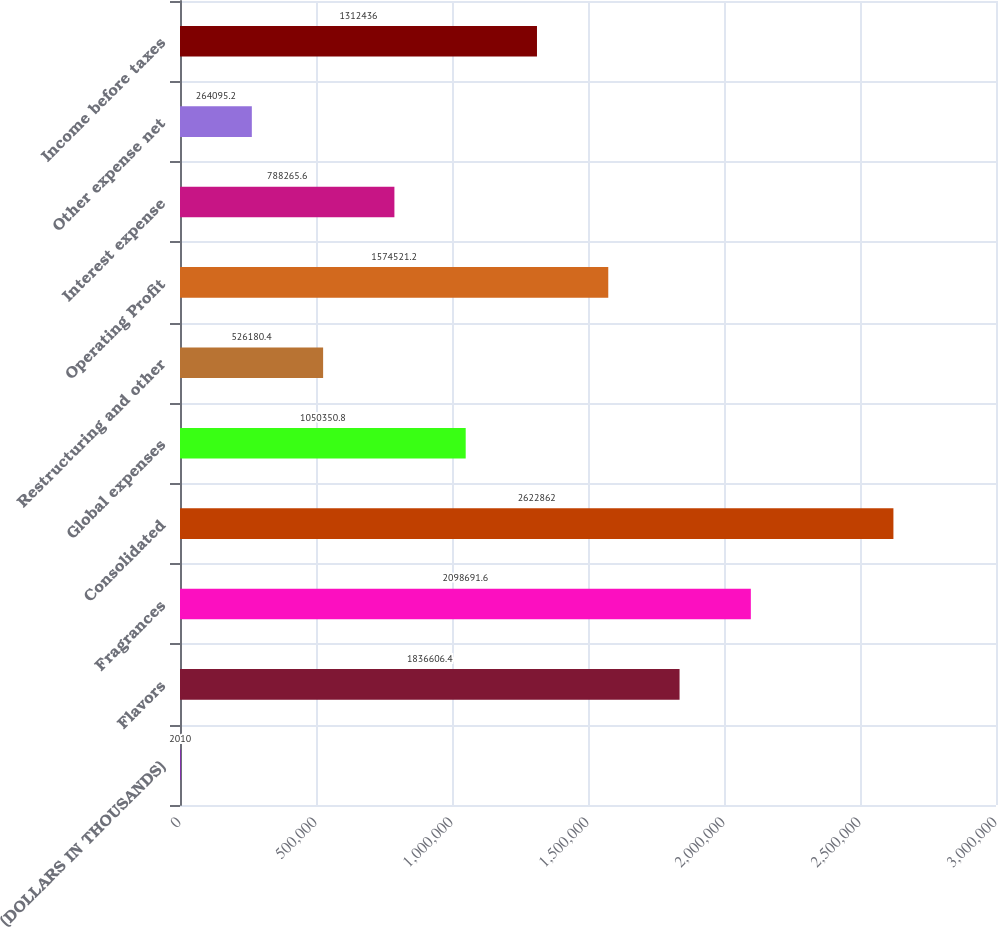Convert chart to OTSL. <chart><loc_0><loc_0><loc_500><loc_500><bar_chart><fcel>(DOLLARS IN THOUSANDS)<fcel>Flavors<fcel>Fragrances<fcel>Consolidated<fcel>Global expenses<fcel>Restructuring and other<fcel>Operating Profit<fcel>Interest expense<fcel>Other expense net<fcel>Income before taxes<nl><fcel>2010<fcel>1.83661e+06<fcel>2.09869e+06<fcel>2.62286e+06<fcel>1.05035e+06<fcel>526180<fcel>1.57452e+06<fcel>788266<fcel>264095<fcel>1.31244e+06<nl></chart> 